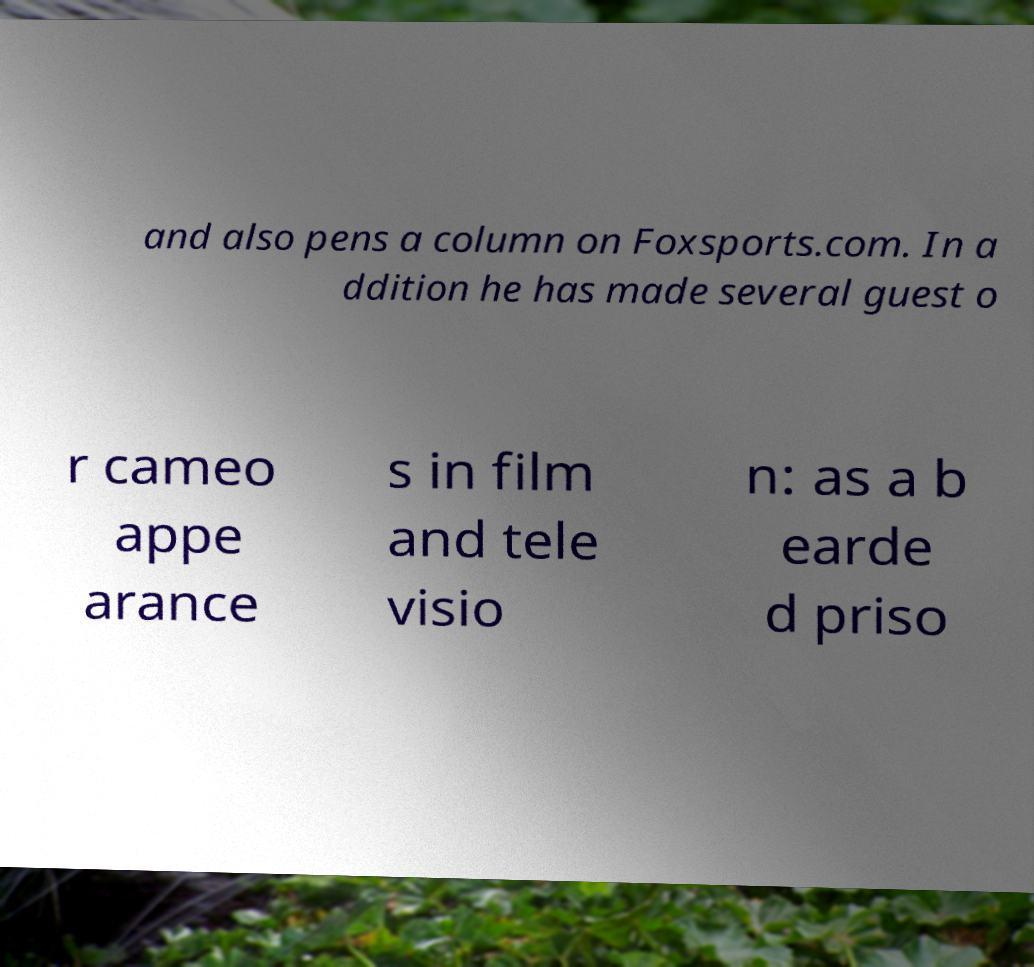Please read and relay the text visible in this image. What does it say? and also pens a column on Foxsports.com. In a ddition he has made several guest o r cameo appe arance s in film and tele visio n: as a b earde d priso 